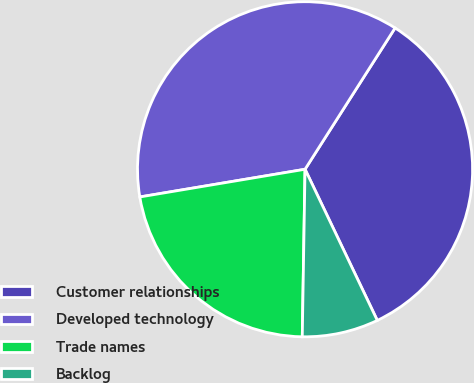Convert chart. <chart><loc_0><loc_0><loc_500><loc_500><pie_chart><fcel>Customer relationships<fcel>Developed technology<fcel>Trade names<fcel>Backlog<nl><fcel>33.87%<fcel>36.67%<fcel>22.09%<fcel>7.36%<nl></chart> 